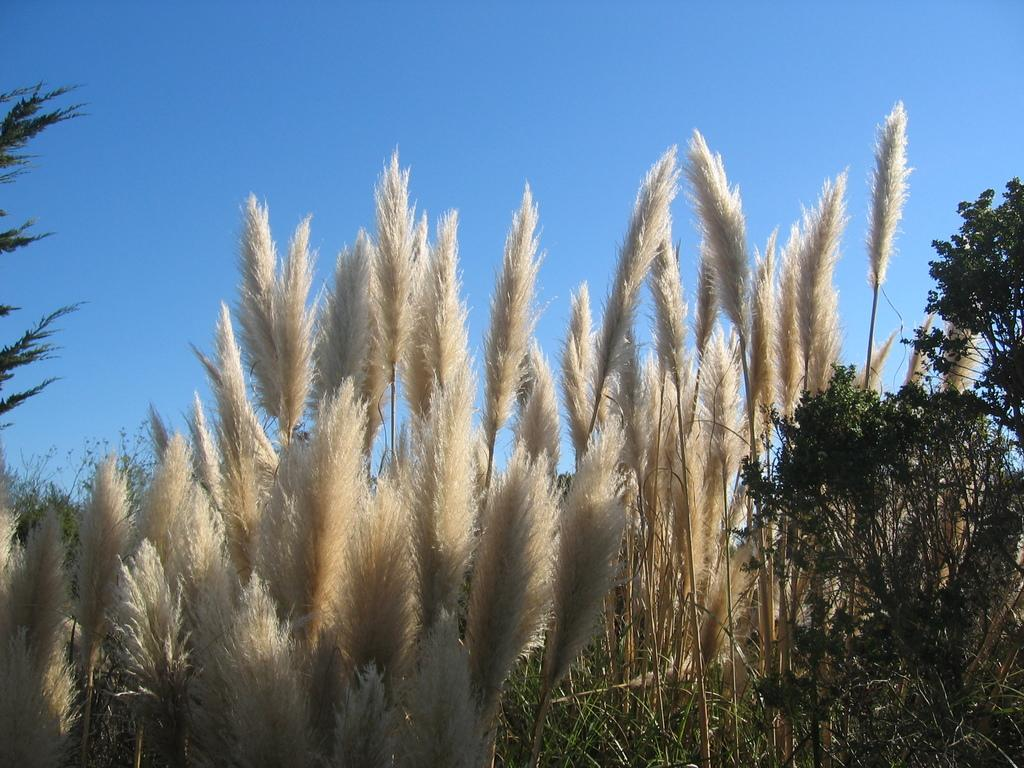What type of living organisms can be seen in the image? Plants can be seen in the image. What colors are the plants in the image? The plants are in green and cream colors. What can be seen in the background of the image? The blue sky is visible in the background of the image. What type of collar can be seen on the doll in the image? There is no doll or collar present in the image; it features plants with green and cream colors against a blue sky background. 